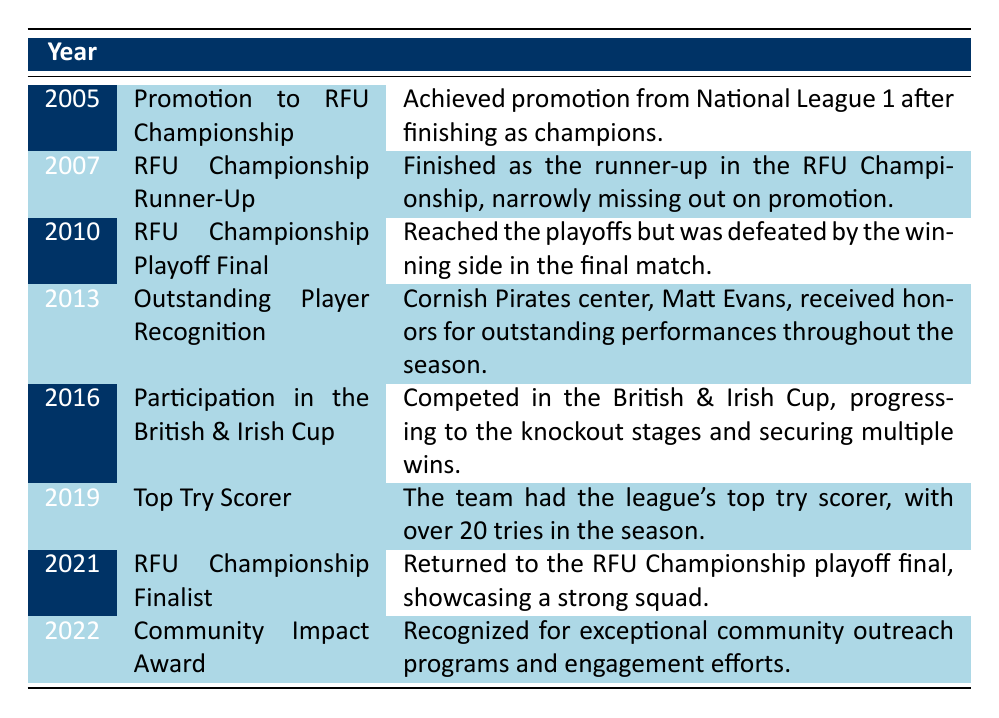What year did Cornish Pirates achieve promotion to the RFU Championship? The table lists the accomplishment of achieving promotion to the RFU Championship in the year 2005.
Answer: 2005 Which achievement did Cornish Pirates earn in 2019? In 2019, Cornish Pirates were recognized as the team with the league's top try scorer, noted for scoring over 20 tries in the season.
Answer: Top Try Scorer Was Cornish Pirates ever recognized for community efforts? Yes, the table shows that in 2022, they received a Community Impact Award for their exceptional outreach programs.
Answer: Yes What was the difference in years between the RFU Championship Runner-Up achievement and the RFU Championship Finalist achievement? The Runner-Up achievement occurred in 2007 and the Finalist in 2021. The difference in years is 2021 - 2007 = 14 years.
Answer: 14 years Which player received outstanding player recognition for the Cornish Pirates? The table states that Matt Evans, a center, received honors for outstanding performances in 2013.
Answer: Matt Evans How many times did Cornish Pirates reach the playoff final based on the table? According to the table, Cornish Pirates reached the playoff final in 2010 and again in 2021. This counts as two instances.
Answer: 2 times In how many different years did Cornish Pirates have notable achievements from 2005 to 2022? The table lists achievements from 2005, 2007, 2010, 2013, 2016, 2019, 2021, and 2022, totaling 8 different years.
Answer: 8 years Which year marked the participation of Cornish Pirates in the British & Irish Cup? The table indicates that the year of participation was 2016.
Answer: 2016 What was the achievement of Cornish Pirates in 2013? The table specifies that in 2013, they were recognized for outstanding player performance, specifically noting Matt Evans.
Answer: Outstanding Player Recognition Did the Cornish Pirates ever finish as champions of the RFU Championship? The table does not indicate that Cornish Pirates finished as champions; they finished as runner-up in 2007 and made finals appearances, but did not claim the title.
Answer: No 